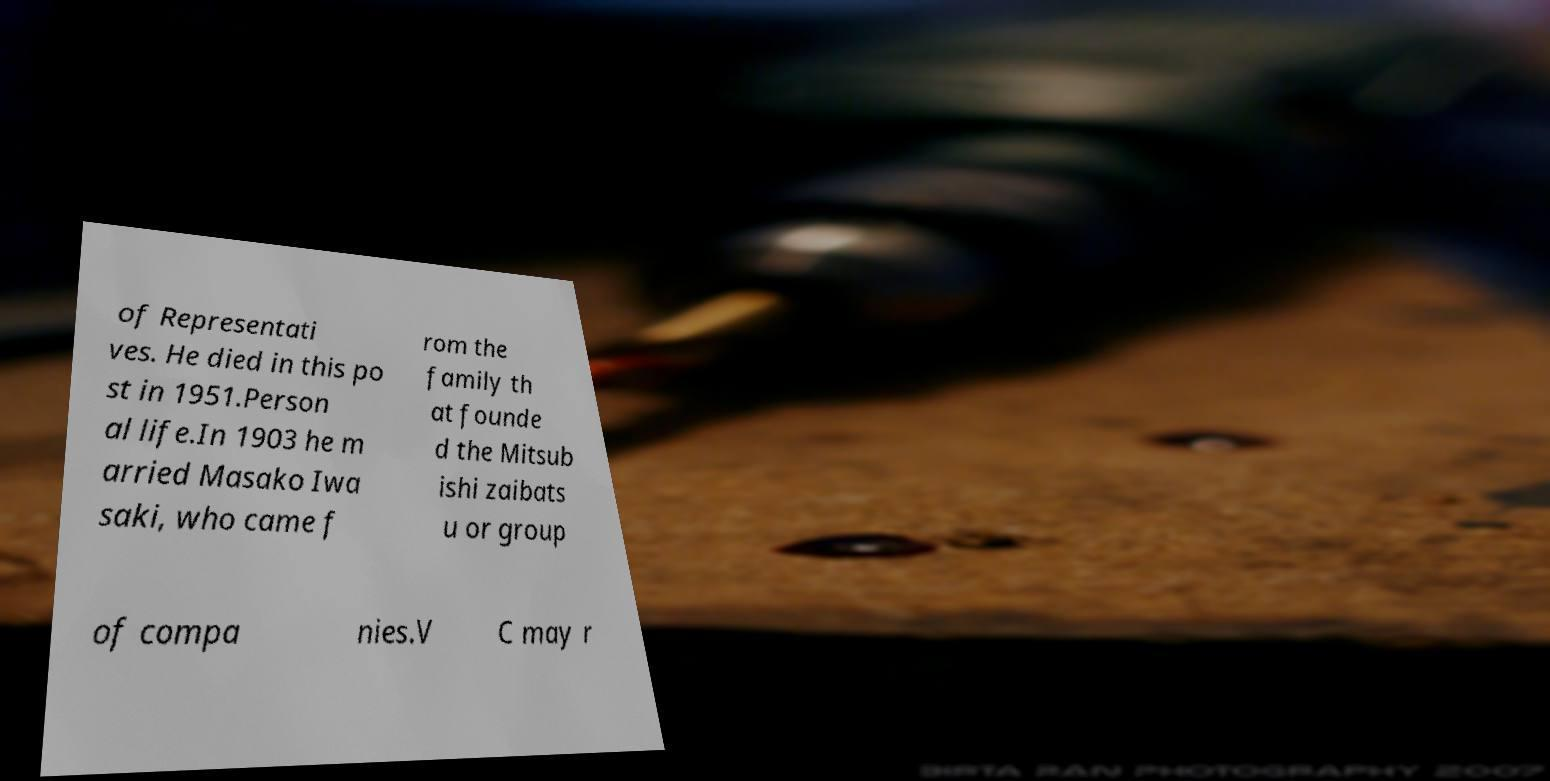Could you assist in decoding the text presented in this image and type it out clearly? of Representati ves. He died in this po st in 1951.Person al life.In 1903 he m arried Masako Iwa saki, who came f rom the family th at founde d the Mitsub ishi zaibats u or group of compa nies.V C may r 